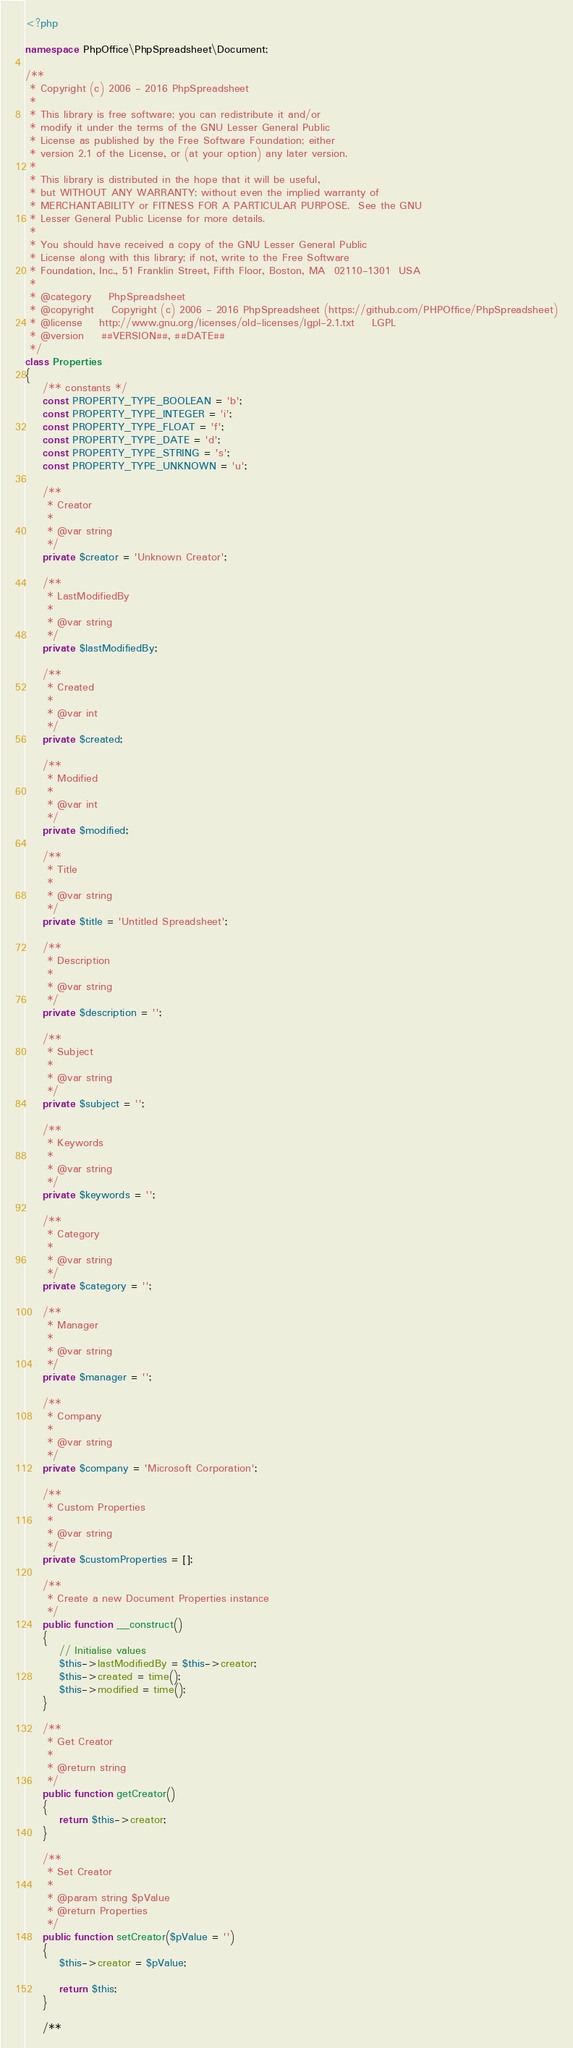<code> <loc_0><loc_0><loc_500><loc_500><_PHP_><?php

namespace PhpOffice\PhpSpreadsheet\Document;

/**
 * Copyright (c) 2006 - 2016 PhpSpreadsheet
 *
 * This library is free software; you can redistribute it and/or
 * modify it under the terms of the GNU Lesser General Public
 * License as published by the Free Software Foundation; either
 * version 2.1 of the License, or (at your option) any later version.
 *
 * This library is distributed in the hope that it will be useful,
 * but WITHOUT ANY WARRANTY; without even the implied warranty of
 * MERCHANTABILITY or FITNESS FOR A PARTICULAR PURPOSE.  See the GNU
 * Lesser General Public License for more details.
 *
 * You should have received a copy of the GNU Lesser General Public
 * License along with this library; if not, write to the Free Software
 * Foundation, Inc., 51 Franklin Street, Fifth Floor, Boston, MA  02110-1301  USA
 *
 * @category    PhpSpreadsheet
 * @copyright    Copyright (c) 2006 - 2016 PhpSpreadsheet (https://github.com/PHPOffice/PhpSpreadsheet)
 * @license    http://www.gnu.org/licenses/old-licenses/lgpl-2.1.txt    LGPL
 * @version    ##VERSION##, ##DATE##
 */
class Properties
{
    /** constants */
    const PROPERTY_TYPE_BOOLEAN = 'b';
    const PROPERTY_TYPE_INTEGER = 'i';
    const PROPERTY_TYPE_FLOAT = 'f';
    const PROPERTY_TYPE_DATE = 'd';
    const PROPERTY_TYPE_STRING = 's';
    const PROPERTY_TYPE_UNKNOWN = 'u';

    /**
     * Creator
     *
     * @var string
     */
    private $creator = 'Unknown Creator';

    /**
     * LastModifiedBy
     *
     * @var string
     */
    private $lastModifiedBy;

    /**
     * Created
     *
     * @var int
     */
    private $created;

    /**
     * Modified
     *
     * @var int
     */
    private $modified;

    /**
     * Title
     *
     * @var string
     */
    private $title = 'Untitled Spreadsheet';

    /**
     * Description
     *
     * @var string
     */
    private $description = '';

    /**
     * Subject
     *
     * @var string
     */
    private $subject = '';

    /**
     * Keywords
     *
     * @var string
     */
    private $keywords = '';

    /**
     * Category
     *
     * @var string
     */
    private $category = '';

    /**
     * Manager
     *
     * @var string
     */
    private $manager = '';

    /**
     * Company
     *
     * @var string
     */
    private $company = 'Microsoft Corporation';

    /**
     * Custom Properties
     *
     * @var string
     */
    private $customProperties = [];

    /**
     * Create a new Document Properties instance
     */
    public function __construct()
    {
        // Initialise values
        $this->lastModifiedBy = $this->creator;
        $this->created = time();
        $this->modified = time();
    }

    /**
     * Get Creator
     *
     * @return string
     */
    public function getCreator()
    {
        return $this->creator;
    }

    /**
     * Set Creator
     *
     * @param string $pValue
     * @return Properties
     */
    public function setCreator($pValue = '')
    {
        $this->creator = $pValue;

        return $this;
    }

    /**</code> 